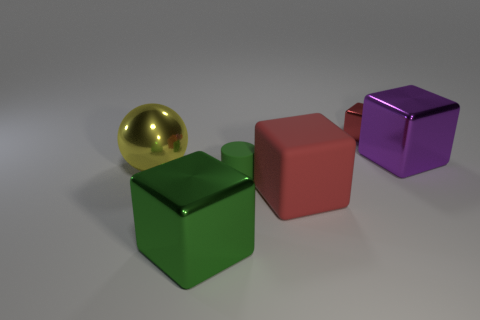Subtract 1 blocks. How many blocks are left? 3 Add 1 small gray balls. How many objects exist? 7 Subtract all cylinders. How many objects are left? 5 Subtract all green metal cylinders. Subtract all small things. How many objects are left? 4 Add 3 big metal blocks. How many big metal blocks are left? 5 Add 3 large red objects. How many large red objects exist? 4 Subtract 0 gray balls. How many objects are left? 6 